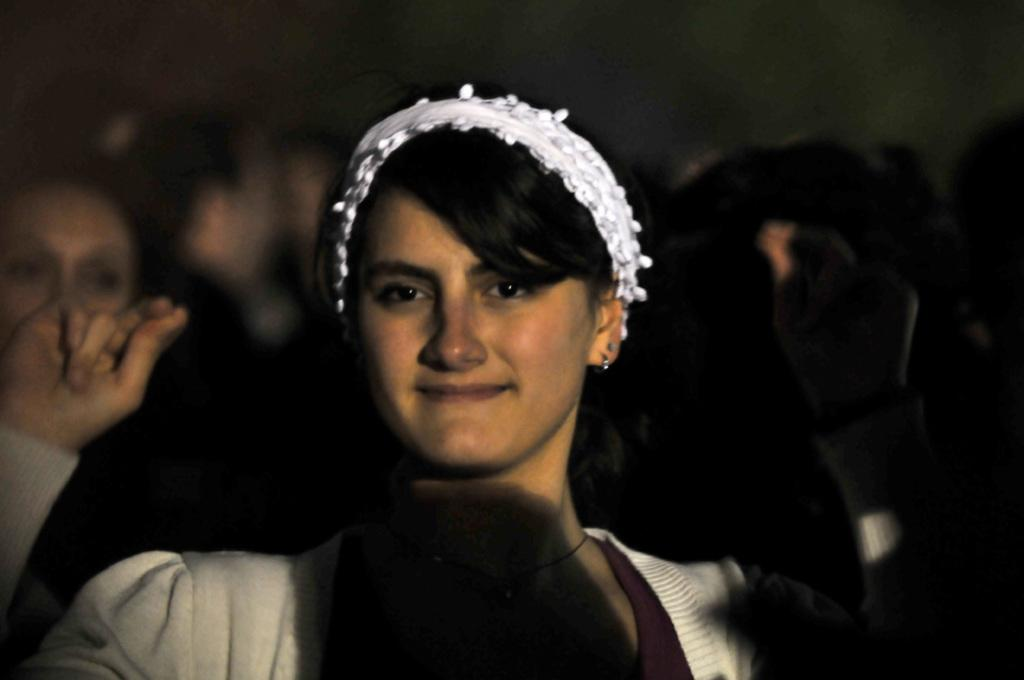Who is the main subject in the image? There is a woman in the image. What is the woman doing in the image? The woman is smiling. Can you describe the background of the image? The background of the image is dark. Are there any other people visible in the image? Yes, there are people in the background of the image. How many sheep can be seen in the image? There are no sheep present in the image. What type of spoon is the woman holding in the image? The woman is not holding a spoon in the image. 